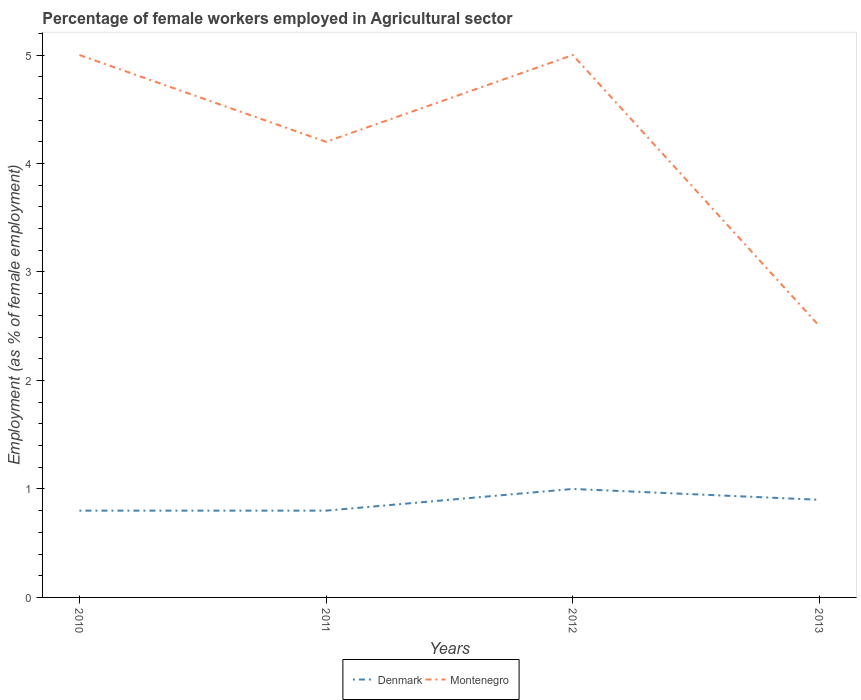How many different coloured lines are there?
Ensure brevity in your answer.  2. Does the line corresponding to Montenegro intersect with the line corresponding to Denmark?
Your answer should be very brief. No. Is the number of lines equal to the number of legend labels?
Provide a succinct answer. Yes. Across all years, what is the maximum percentage of females employed in Agricultural sector in Montenegro?
Keep it short and to the point. 2.5. What is the total percentage of females employed in Agricultural sector in Denmark in the graph?
Give a very brief answer. -0.1. What is the difference between the highest and the second highest percentage of females employed in Agricultural sector in Denmark?
Make the answer very short. 0.2. How many lines are there?
Keep it short and to the point. 2. Are the values on the major ticks of Y-axis written in scientific E-notation?
Ensure brevity in your answer.  No. Does the graph contain any zero values?
Offer a terse response. No. Does the graph contain grids?
Keep it short and to the point. No. How many legend labels are there?
Ensure brevity in your answer.  2. What is the title of the graph?
Give a very brief answer. Percentage of female workers employed in Agricultural sector. Does "Australia" appear as one of the legend labels in the graph?
Your answer should be very brief. No. What is the label or title of the X-axis?
Offer a very short reply. Years. What is the label or title of the Y-axis?
Keep it short and to the point. Employment (as % of female employment). What is the Employment (as % of female employment) of Denmark in 2010?
Your answer should be compact. 0.8. What is the Employment (as % of female employment) in Montenegro in 2010?
Offer a terse response. 5. What is the Employment (as % of female employment) of Denmark in 2011?
Offer a very short reply. 0.8. What is the Employment (as % of female employment) in Montenegro in 2011?
Provide a short and direct response. 4.2. What is the Employment (as % of female employment) in Montenegro in 2012?
Offer a terse response. 5. What is the Employment (as % of female employment) in Denmark in 2013?
Your answer should be compact. 0.9. What is the Employment (as % of female employment) in Montenegro in 2013?
Offer a very short reply. 2.5. Across all years, what is the maximum Employment (as % of female employment) in Denmark?
Offer a terse response. 1. Across all years, what is the minimum Employment (as % of female employment) in Denmark?
Your answer should be very brief. 0.8. What is the total Employment (as % of female employment) of Denmark in the graph?
Keep it short and to the point. 3.5. What is the total Employment (as % of female employment) in Montenegro in the graph?
Your response must be concise. 16.7. What is the difference between the Employment (as % of female employment) in Denmark in 2010 and that in 2011?
Provide a succinct answer. 0. What is the difference between the Employment (as % of female employment) in Montenegro in 2010 and that in 2012?
Keep it short and to the point. 0. What is the difference between the Employment (as % of female employment) of Denmark in 2011 and that in 2012?
Ensure brevity in your answer.  -0.2. What is the difference between the Employment (as % of female employment) in Denmark in 2011 and that in 2013?
Ensure brevity in your answer.  -0.1. What is the difference between the Employment (as % of female employment) in Denmark in 2010 and the Employment (as % of female employment) in Montenegro in 2013?
Provide a short and direct response. -1.7. What is the difference between the Employment (as % of female employment) of Denmark in 2011 and the Employment (as % of female employment) of Montenegro in 2013?
Provide a short and direct response. -1.7. What is the difference between the Employment (as % of female employment) of Denmark in 2012 and the Employment (as % of female employment) of Montenegro in 2013?
Offer a very short reply. -1.5. What is the average Employment (as % of female employment) in Denmark per year?
Provide a short and direct response. 0.88. What is the average Employment (as % of female employment) of Montenegro per year?
Give a very brief answer. 4.17. In the year 2010, what is the difference between the Employment (as % of female employment) in Denmark and Employment (as % of female employment) in Montenegro?
Give a very brief answer. -4.2. In the year 2013, what is the difference between the Employment (as % of female employment) in Denmark and Employment (as % of female employment) in Montenegro?
Your answer should be compact. -1.6. What is the ratio of the Employment (as % of female employment) of Denmark in 2010 to that in 2011?
Your answer should be compact. 1. What is the ratio of the Employment (as % of female employment) in Montenegro in 2010 to that in 2011?
Your answer should be very brief. 1.19. What is the ratio of the Employment (as % of female employment) of Denmark in 2010 to that in 2012?
Keep it short and to the point. 0.8. What is the ratio of the Employment (as % of female employment) in Montenegro in 2011 to that in 2012?
Make the answer very short. 0.84. What is the ratio of the Employment (as % of female employment) of Montenegro in 2011 to that in 2013?
Your answer should be compact. 1.68. What is the difference between the highest and the second highest Employment (as % of female employment) in Denmark?
Provide a succinct answer. 0.1. What is the difference between the highest and the second highest Employment (as % of female employment) of Montenegro?
Make the answer very short. 0. What is the difference between the highest and the lowest Employment (as % of female employment) in Denmark?
Ensure brevity in your answer.  0.2. What is the difference between the highest and the lowest Employment (as % of female employment) in Montenegro?
Provide a short and direct response. 2.5. 